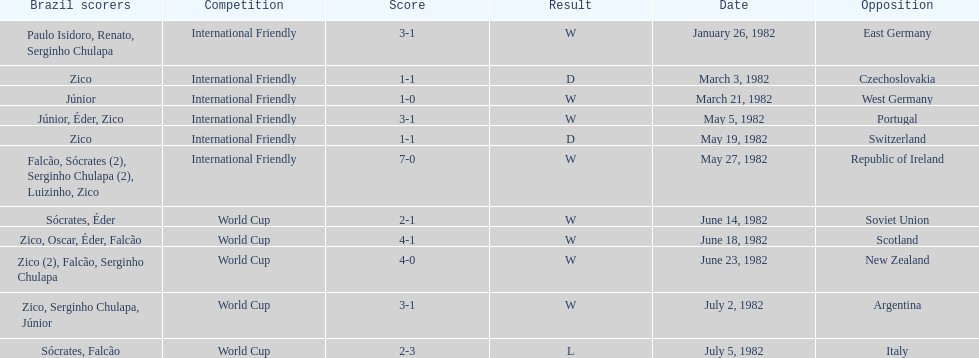What date is at the top of the list? January 26, 1982. 